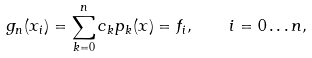<formula> <loc_0><loc_0><loc_500><loc_500>g _ { n } ( x _ { i } ) = \sum _ { k = 0 } ^ { n } c _ { k } p _ { k } ( x ) = f _ { i } , \quad i = 0 \dots n ,</formula> 